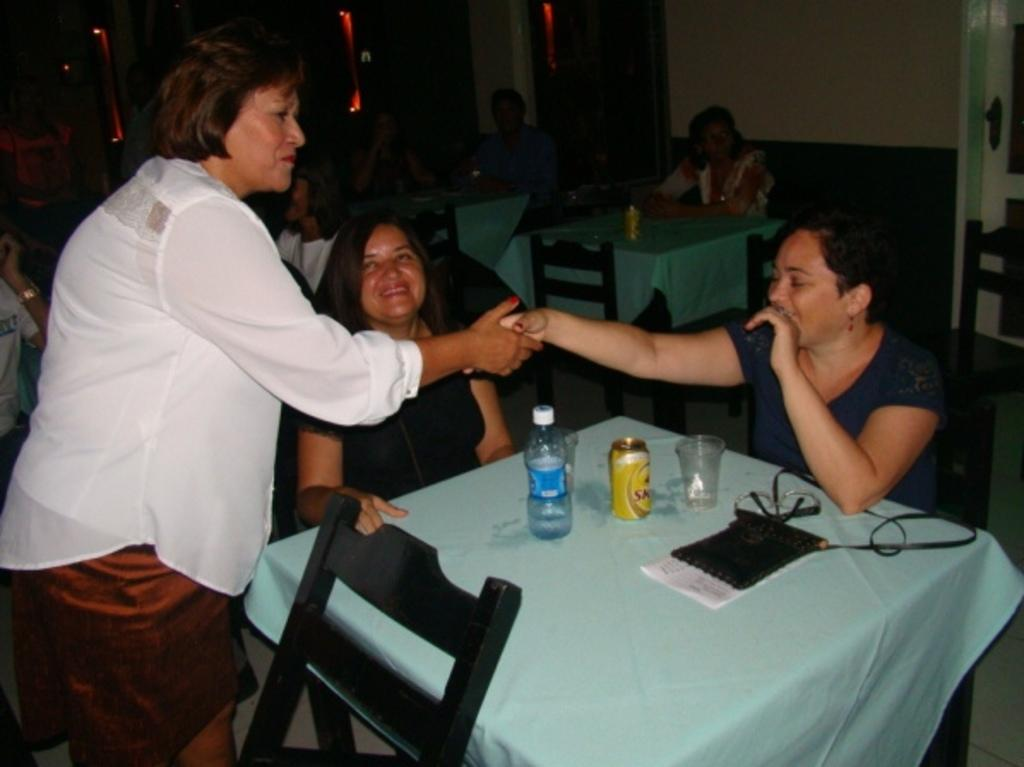How many women are in the image? There are three women in the image. What can be seen near the women? The women are near a table. What items are on the table? There is a water bottle, glasses, a tin, and a bag on the table. Are there any other people visible in the image? Yes, there are more people visible in the background of the image. What type of flowers are in the eggnog that the women are drinking in the image? There is no eggnog or flowers present in the image. The women are not depicted as drinking anything. 